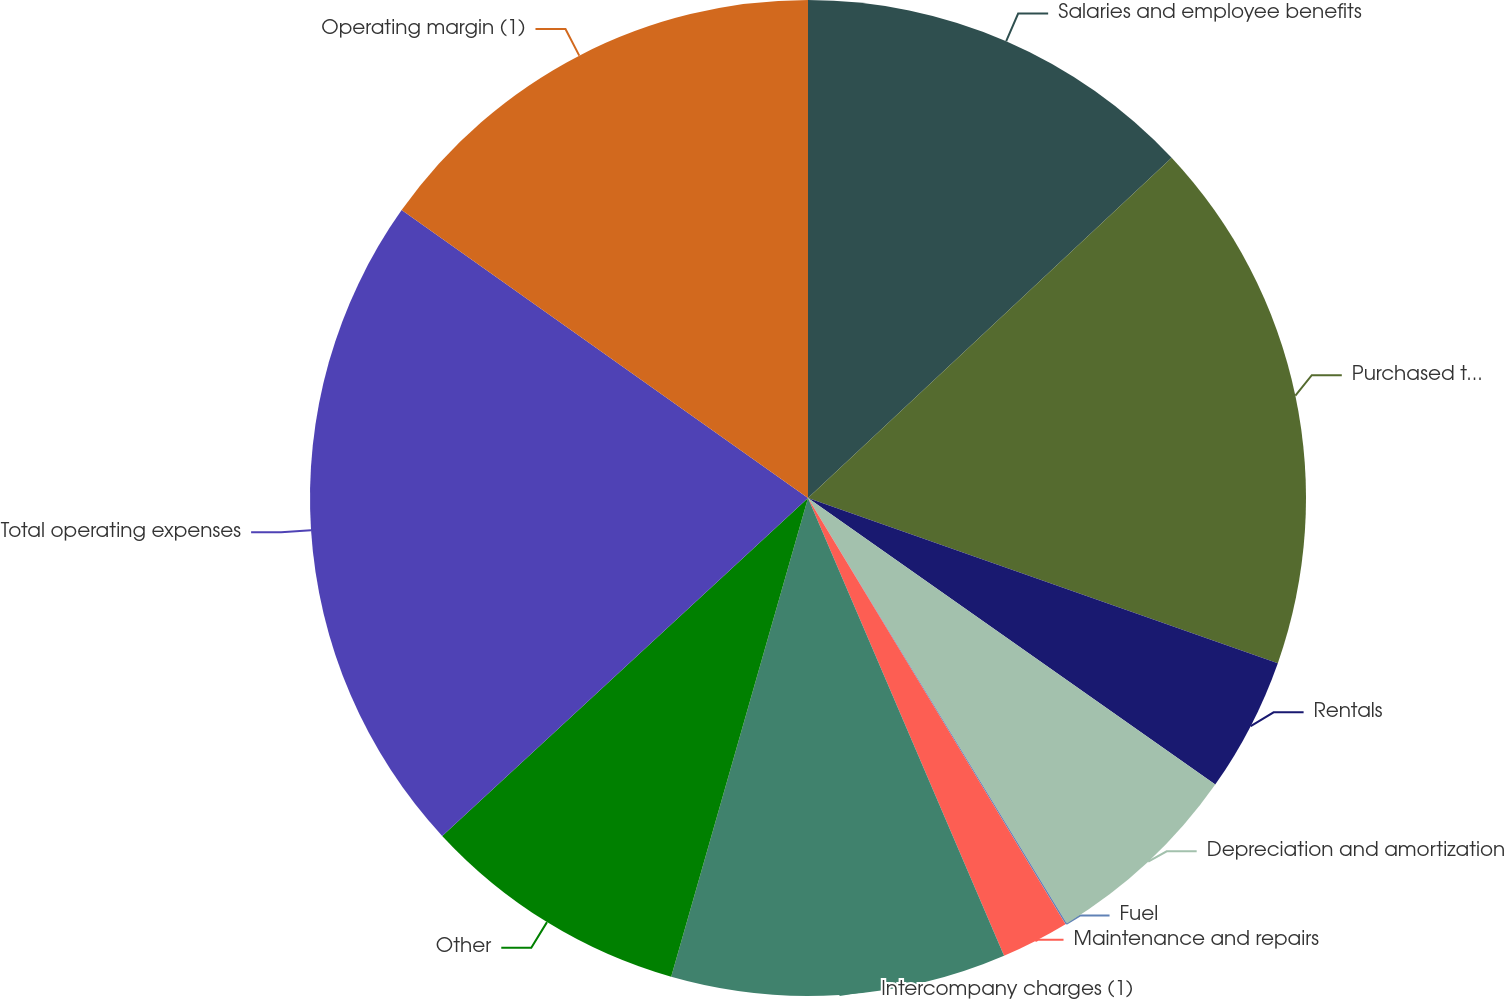<chart> <loc_0><loc_0><loc_500><loc_500><pie_chart><fcel>Salaries and employee benefits<fcel>Purchased transportation<fcel>Rentals<fcel>Depreciation and amortization<fcel>Fuel<fcel>Maintenance and repairs<fcel>Intercompany charges (1)<fcel>Other<fcel>Total operating expenses<fcel>Operating margin (1)<nl><fcel>13.03%<fcel>17.35%<fcel>4.38%<fcel>6.54%<fcel>0.05%<fcel>2.21%<fcel>10.87%<fcel>8.7%<fcel>21.68%<fcel>15.19%<nl></chart> 